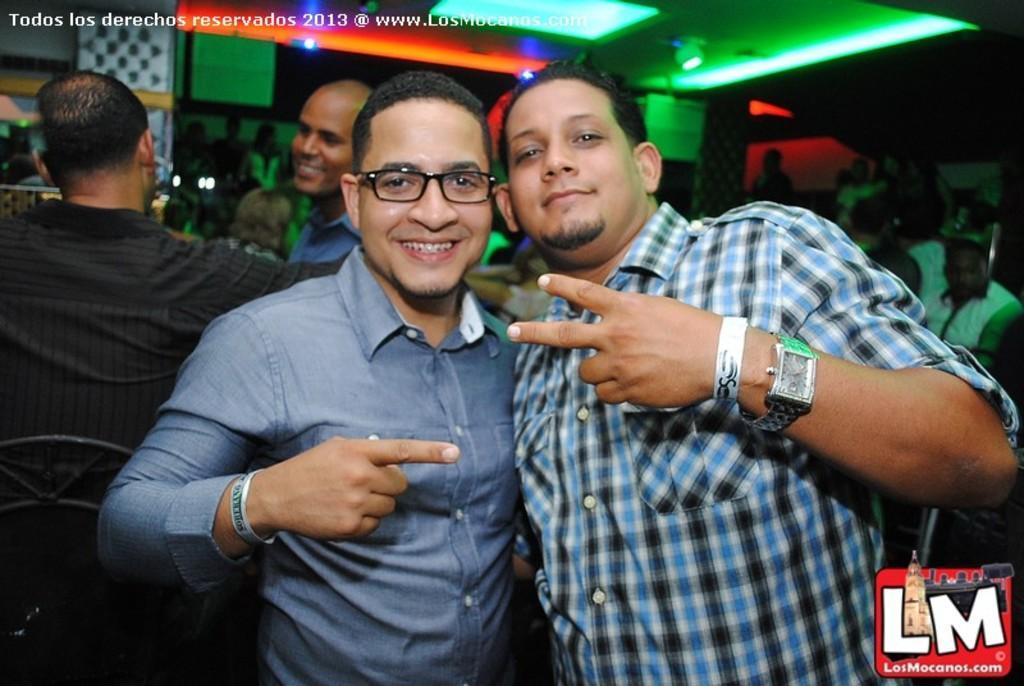Could you give a brief overview of what you see in this image? This is an inside view. Here I can see two men standing, smiling and giving pose for the picture. On the left side there are two persons. One person is sitting on a chair. In the background, I can see many people in the dark. At the top of the image there are few lights and some text. 